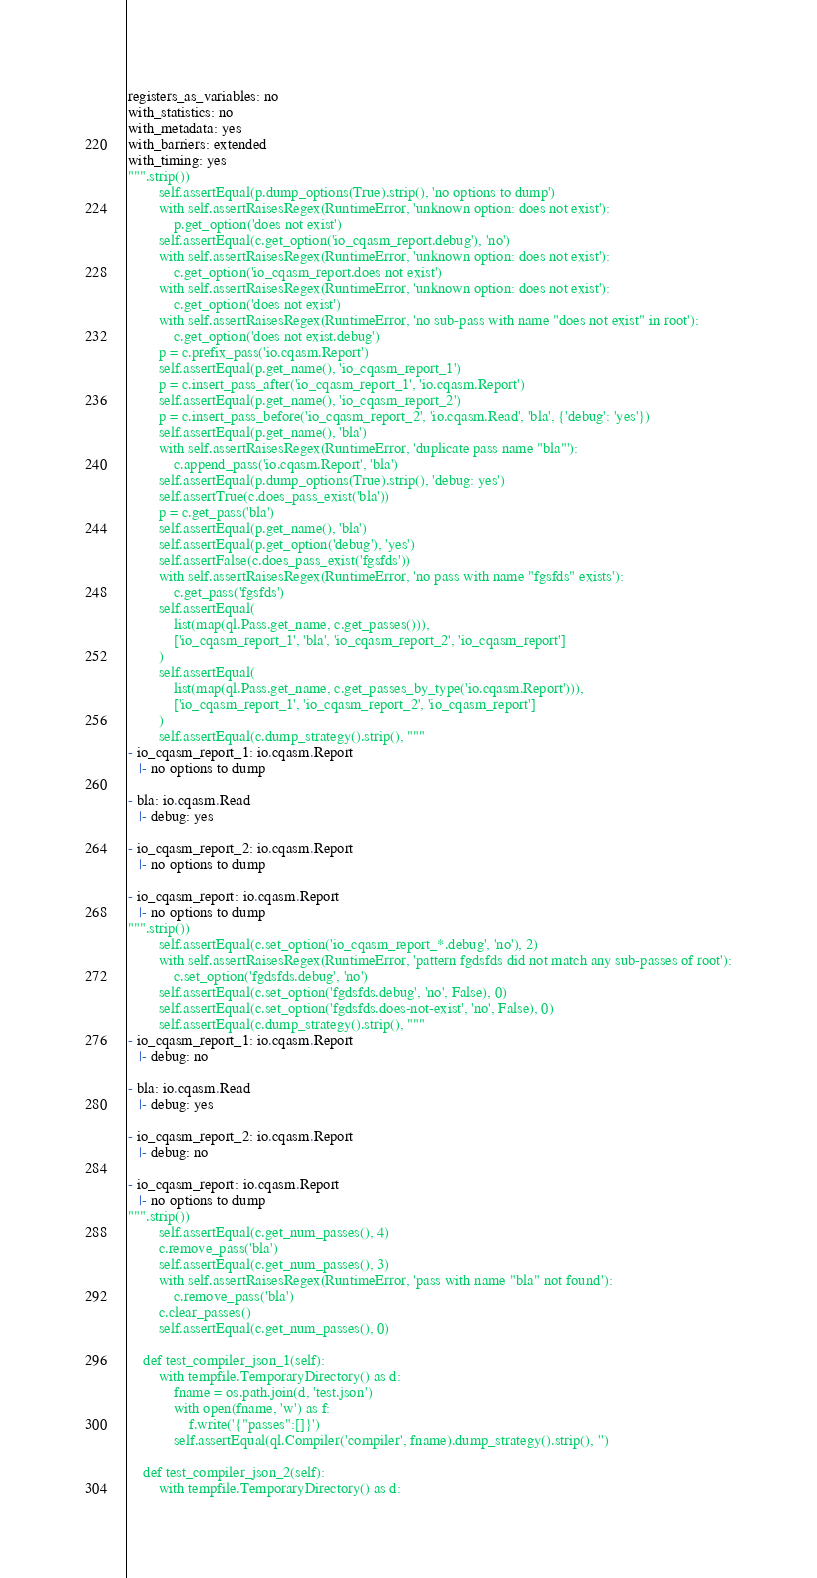Convert code to text. <code><loc_0><loc_0><loc_500><loc_500><_Python_>registers_as_variables: no
with_statistics: no
with_metadata: yes
with_barriers: extended
with_timing: yes
""".strip())
        self.assertEqual(p.dump_options(True).strip(), 'no options to dump')
        with self.assertRaisesRegex(RuntimeError, 'unknown option: does not exist'):
            p.get_option('does not exist')
        self.assertEqual(c.get_option('io_cqasm_report.debug'), 'no')
        with self.assertRaisesRegex(RuntimeError, 'unknown option: does not exist'):
            c.get_option('io_cqasm_report.does not exist')
        with self.assertRaisesRegex(RuntimeError, 'unknown option: does not exist'):
            c.get_option('does not exist')
        with self.assertRaisesRegex(RuntimeError, 'no sub-pass with name "does not exist" in root'):
            c.get_option('does not exist.debug')
        p = c.prefix_pass('io.cqasm.Report')
        self.assertEqual(p.get_name(), 'io_cqasm_report_1')
        p = c.insert_pass_after('io_cqasm_report_1', 'io.cqasm.Report')
        self.assertEqual(p.get_name(), 'io_cqasm_report_2')
        p = c.insert_pass_before('io_cqasm_report_2', 'io.cqasm.Read', 'bla', {'debug': 'yes'})
        self.assertEqual(p.get_name(), 'bla')
        with self.assertRaisesRegex(RuntimeError, 'duplicate pass name "bla"'):
            c.append_pass('io.cqasm.Report', 'bla')
        self.assertEqual(p.dump_options(True).strip(), 'debug: yes')
        self.assertTrue(c.does_pass_exist('bla'))
        p = c.get_pass('bla')
        self.assertEqual(p.get_name(), 'bla')
        self.assertEqual(p.get_option('debug'), 'yes')
        self.assertFalse(c.does_pass_exist('fgsfds'))
        with self.assertRaisesRegex(RuntimeError, 'no pass with name "fgsfds" exists'):
            c.get_pass('fgsfds')
        self.assertEqual(
            list(map(ql.Pass.get_name, c.get_passes())),
            ['io_cqasm_report_1', 'bla', 'io_cqasm_report_2', 'io_cqasm_report']
        )
        self.assertEqual(
            list(map(ql.Pass.get_name, c.get_passes_by_type('io.cqasm.Report'))),
            ['io_cqasm_report_1', 'io_cqasm_report_2', 'io_cqasm_report']
        )
        self.assertEqual(c.dump_strategy().strip(), """
- io_cqasm_report_1: io.cqasm.Report
   |- no options to dump

- bla: io.cqasm.Read
   |- debug: yes

- io_cqasm_report_2: io.cqasm.Report
   |- no options to dump

- io_cqasm_report: io.cqasm.Report
   |- no options to dump
""".strip())
        self.assertEqual(c.set_option('io_cqasm_report_*.debug', 'no'), 2)
        with self.assertRaisesRegex(RuntimeError, 'pattern fgdsfds did not match any sub-passes of root'):
            c.set_option('fgdsfds.debug', 'no')
        self.assertEqual(c.set_option('fgdsfds.debug', 'no', False), 0)
        self.assertEqual(c.set_option('fgdsfds.does-not-exist', 'no', False), 0)
        self.assertEqual(c.dump_strategy().strip(), """
- io_cqasm_report_1: io.cqasm.Report
   |- debug: no

- bla: io.cqasm.Read
   |- debug: yes

- io_cqasm_report_2: io.cqasm.Report
   |- debug: no

- io_cqasm_report: io.cqasm.Report
   |- no options to dump
""".strip())
        self.assertEqual(c.get_num_passes(), 4)
        c.remove_pass('bla')
        self.assertEqual(c.get_num_passes(), 3)
        with self.assertRaisesRegex(RuntimeError, 'pass with name "bla" not found'):
            c.remove_pass('bla')
        c.clear_passes()
        self.assertEqual(c.get_num_passes(), 0)

    def test_compiler_json_1(self):
        with tempfile.TemporaryDirectory() as d:
            fname = os.path.join(d, 'test.json')
            with open(fname, 'w') as f:
                f.write('{"passes":[]}')
            self.assertEqual(ql.Compiler('compiler', fname).dump_strategy().strip(), '')

    def test_compiler_json_2(self):
        with tempfile.TemporaryDirectory() as d:</code> 